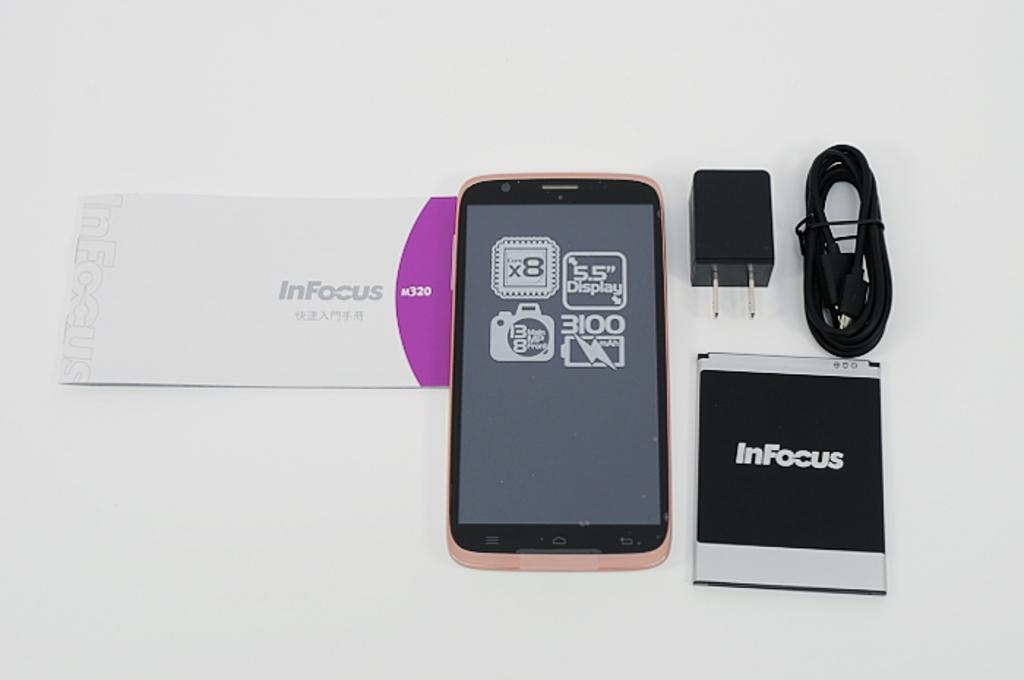<image>
Describe the image concisely. Several Android display screen with one reading "InFocus" on the screen. 